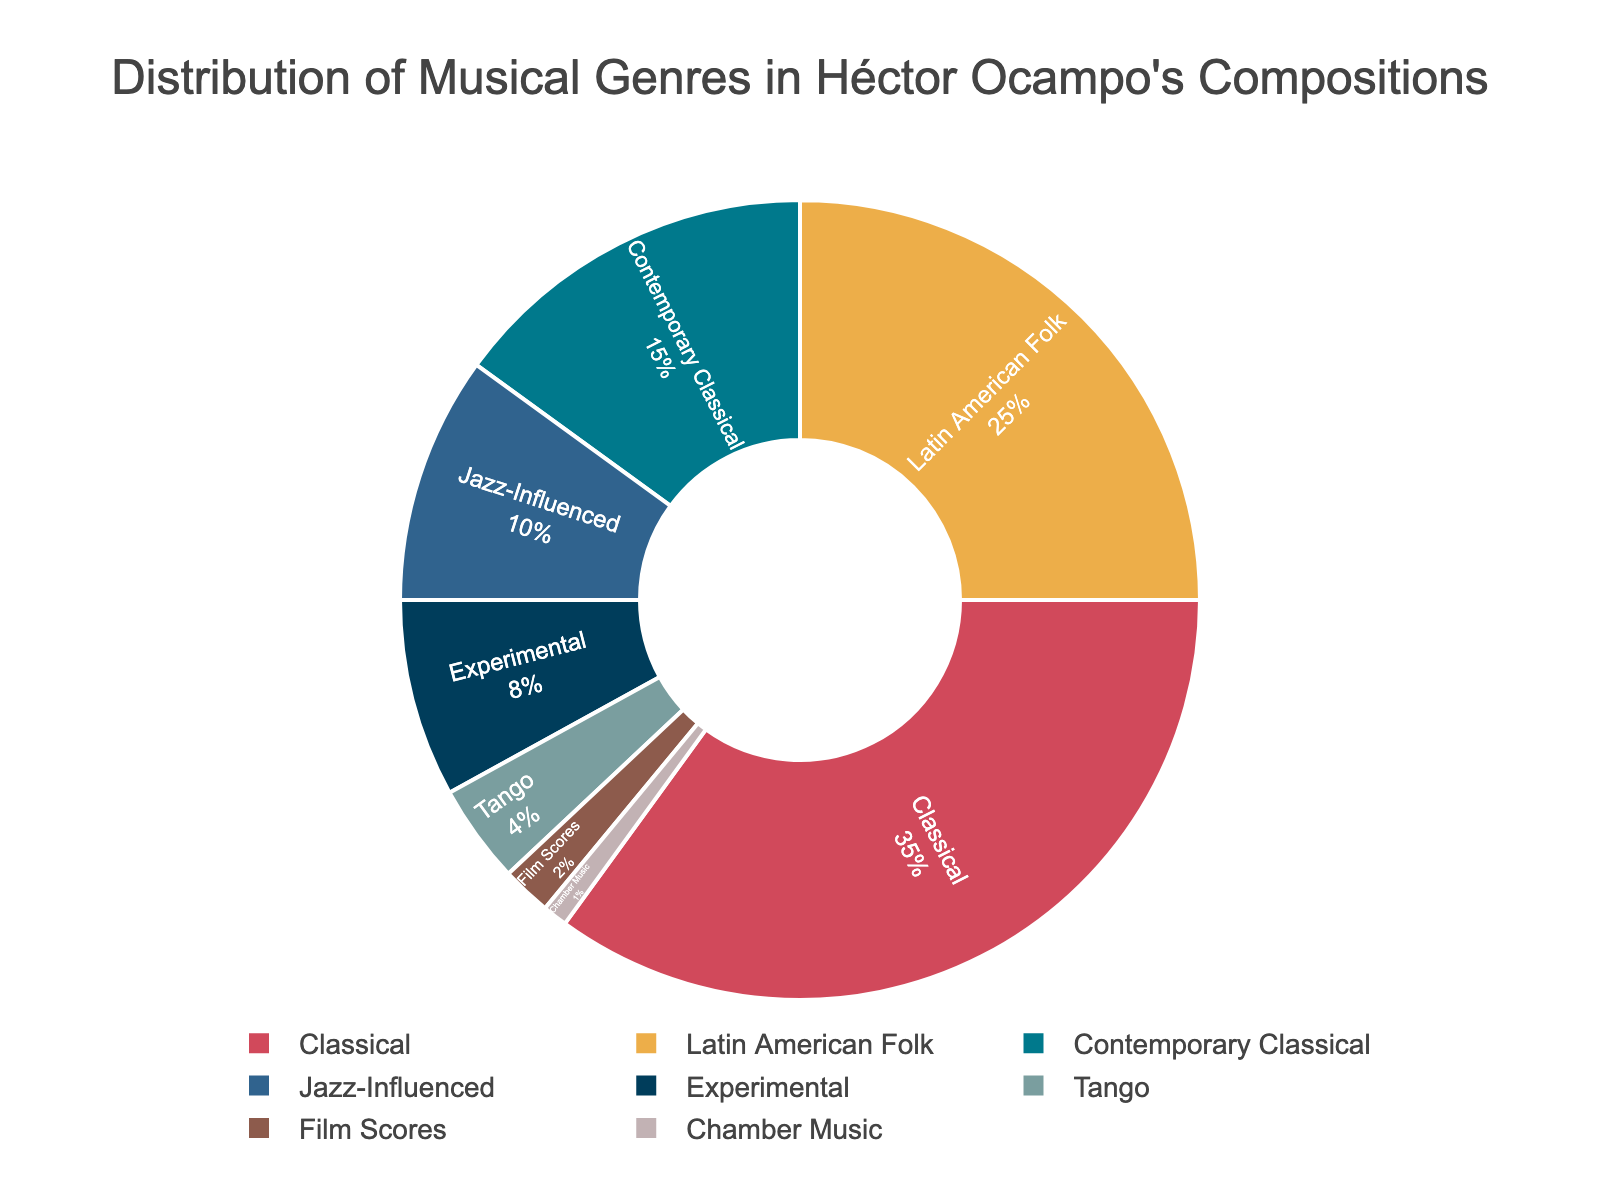How much of Héctor Ocampo's compositions are classified as Jazz-Influenced and Experimental combined? Add the percentages of Jazz-Influenced (10%) and Experimental (8%). 10 + 8 = 18
Answer: 18% Which genre occupies a larger portion in the figure: Latin American Folk or Classical? Compare the percentages of Latin American Folk (25%) and Classical (35%). Classical is larger.
Answer: Classical What percentage of Héctor Ocampo's compositions is dedicated to Tango? Refer to the segment labeled Tango in the pie chart to find its percentage, which is 4%.
Answer: 4% How much more percentage does the Classical genre occupy compared to Contemporary Classical? Subtract the percentage of Contemporary Classical (15%) from Classical (35%) to find the difference. 35 - 15 = 20
Answer: 20 Which genre is represented by the fourth segment clockwise from the top? Observe the pie chart starting from the top and count four segments clockwise. The fourth segment is Jazz-Influenced at 10%.
Answer: Jazz-Influenced How many genres have less than a 10% share in Héctor Ocampo's compositions? Sum up the proportions for genres with less than 10% which are Experimental (8%), Tango (4%), Film Scores (2%), and Chamber Music (1%). Count the number of these genres, which is 4.
Answer: 4 What is the combined percentage of genres that make up less than 5% in Héctor Ocampo's compositions? Add the percentages of the genres with less than 5%, which are Tango (4%), Film Scores (2%), and Chamber Music (1%). 4 + 2 + 1 = 7
Answer: 7% Between Experimental and Film Scores, which genre appears more frequently in Héctor Ocampo's compositions? Compare the percentages: Experimental (8%) and Film Scores (2%). Experimental is more frequent.
Answer: Experimental What is the average percentage of genres that occupy more than 10% each? Sum the percentages of genres with more than 10% (Classical 35%, Latin American Folk 25%, Contemporary Classical 15%) and divide by the number of those genres. (35 + 25 + 15)/3 = 75/3 = 25
Answer: 25 What color is used for the Classical genre in the pie chart? Identify the color used for the Classical segment, which is usually the largest and can be cross-referenced with the legend to see it corresponds to the shade of red in the chart.
Answer: Red 